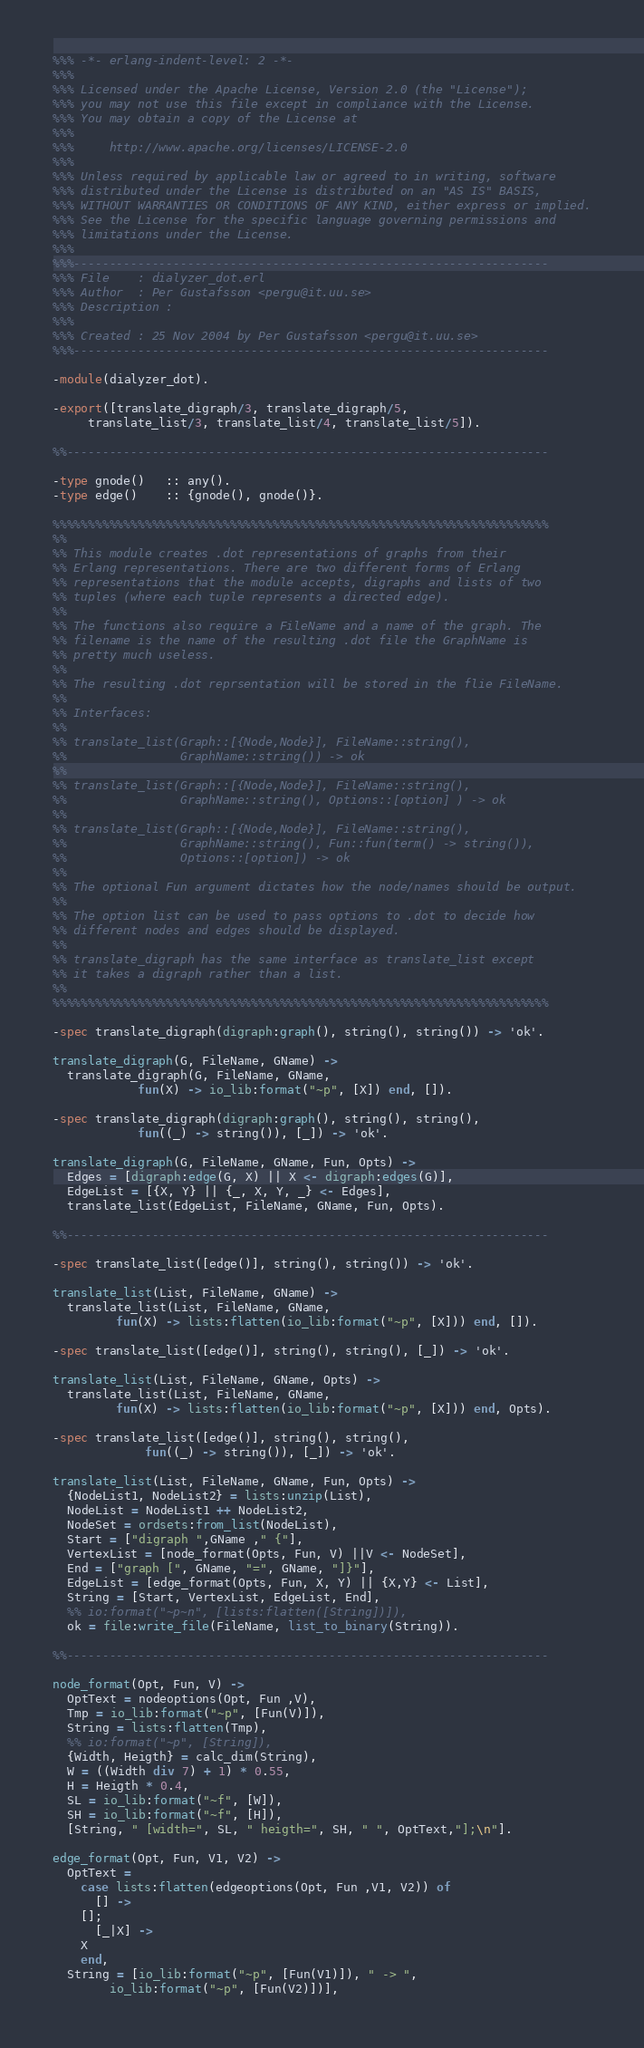<code> <loc_0><loc_0><loc_500><loc_500><_Erlang_>%%% -*- erlang-indent-level: 2 -*-
%%%
%%% Licensed under the Apache License, Version 2.0 (the "License");
%%% you may not use this file except in compliance with the License.
%%% You may obtain a copy of the License at
%%%
%%%     http://www.apache.org/licenses/LICENSE-2.0
%%%
%%% Unless required by applicable law or agreed to in writing, software
%%% distributed under the License is distributed on an "AS IS" BASIS,
%%% WITHOUT WARRANTIES OR CONDITIONS OF ANY KIND, either express or implied.
%%% See the License for the specific language governing permissions and
%%% limitations under the License.
%%%
%%%-------------------------------------------------------------------
%%% File    : dialyzer_dot.erl
%%% Author  : Per Gustafsson <pergu@it.uu.se>
%%% Description :
%%%
%%% Created : 25 Nov 2004 by Per Gustafsson <pergu@it.uu.se>
%%%-------------------------------------------------------------------

-module(dialyzer_dot).

-export([translate_digraph/3, translate_digraph/5,
	 translate_list/3, translate_list/4, translate_list/5]).

%%--------------------------------------------------------------------

-type gnode()   :: any().
-type edge()    :: {gnode(), gnode()}.

%%%%%%%%%%%%%%%%%%%%%%%%%%%%%%%%%%%%%%%%%%%%%%%%%%%%%%%%%%%%%%%%%%%%%%
%%
%% This module creates .dot representations of graphs from their
%% Erlang representations. There are two different forms of Erlang
%% representations that the module accepts, digraphs and lists of two
%% tuples (where each tuple represents a directed edge).
%%
%% The functions also require a FileName and a name of the graph. The
%% filename is the name of the resulting .dot file the GraphName is
%% pretty much useless.
%%
%% The resulting .dot reprsentation will be stored in the flie FileName.
%%
%% Interfaces:
%%
%% translate_list(Graph::[{Node,Node}], FileName::string(),
%%                GraphName::string()) -> ok
%%
%% translate_list(Graph::[{Node,Node}], FileName::string(),
%%                GraphName::string(), Options::[option] ) -> ok
%%
%% translate_list(Graph::[{Node,Node}], FileName::string(),
%%                GraphName::string(), Fun::fun(term() -> string()),
%%                Options::[option]) -> ok
%%
%% The optional Fun argument dictates how the node/names should be output.
%%
%% The option list can be used to pass options to .dot to decide how
%% different nodes and edges should be displayed.
%%
%% translate_digraph has the same interface as translate_list except
%% it takes a digraph rather than a list.
%%
%%%%%%%%%%%%%%%%%%%%%%%%%%%%%%%%%%%%%%%%%%%%%%%%%%%%%%%%%%%%%%%%%%%%%%

-spec translate_digraph(digraph:graph(), string(), string()) -> 'ok'.

translate_digraph(G, FileName, GName) ->
  translate_digraph(G, FileName, GName,
		    fun(X) -> io_lib:format("~p", [X]) end, []).

-spec translate_digraph(digraph:graph(), string(), string(),
			fun((_) -> string()), [_]) -> 'ok'.

translate_digraph(G, FileName, GName, Fun, Opts) ->
  Edges = [digraph:edge(G, X) || X <- digraph:edges(G)],
  EdgeList = [{X, Y} || {_, X, Y, _} <- Edges],
  translate_list(EdgeList, FileName, GName, Fun, Opts).

%%--------------------------------------------------------------------

-spec translate_list([edge()], string(), string()) -> 'ok'.

translate_list(List, FileName, GName) ->
  translate_list(List, FileName, GName,
		 fun(X) -> lists:flatten(io_lib:format("~p", [X])) end, []).

-spec translate_list([edge()], string(), string(), [_]) -> 'ok'.

translate_list(List, FileName, GName, Opts) ->
  translate_list(List, FileName, GName,
		 fun(X) -> lists:flatten(io_lib:format("~p", [X])) end, Opts).

-spec translate_list([edge()], string(), string(),
		     fun((_) -> string()), [_]) -> 'ok'.

translate_list(List, FileName, GName, Fun, Opts) ->
  {NodeList1, NodeList2} = lists:unzip(List),
  NodeList = NodeList1 ++ NodeList2,
  NodeSet = ordsets:from_list(NodeList),
  Start = ["digraph ",GName ," {"],
  VertexList = [node_format(Opts, Fun, V) ||V <- NodeSet],
  End = ["graph [", GName, "=", GName, "]}"],
  EdgeList = [edge_format(Opts, Fun, X, Y) || {X,Y} <- List],
  String = [Start, VertexList, EdgeList, End],
  %% io:format("~p~n", [lists:flatten([String])]),
  ok = file:write_file(FileName, list_to_binary(String)).

%%--------------------------------------------------------------------

node_format(Opt, Fun, V) ->
  OptText = nodeoptions(Opt, Fun ,V),
  Tmp = io_lib:format("~p", [Fun(V)]),
  String = lists:flatten(Tmp),
  %% io:format("~p", [String]),
  {Width, Heigth} = calc_dim(String),
  W = ((Width div 7) + 1) * 0.55,
  H = Heigth * 0.4,
  SL = io_lib:format("~f", [W]),
  SH = io_lib:format("~f", [H]),
  [String, " [width=", SL, " heigth=", SH, " ", OptText,"];\n"].

edge_format(Opt, Fun, V1, V2) ->
  OptText =
    case lists:flatten(edgeoptions(Opt, Fun ,V1, V2)) of
      [] ->
	[];
      [_|X] ->
	X
    end,
  String = [io_lib:format("~p", [Fun(V1)]), " -> ",
	    io_lib:format("~p", [Fun(V2)])],</code> 